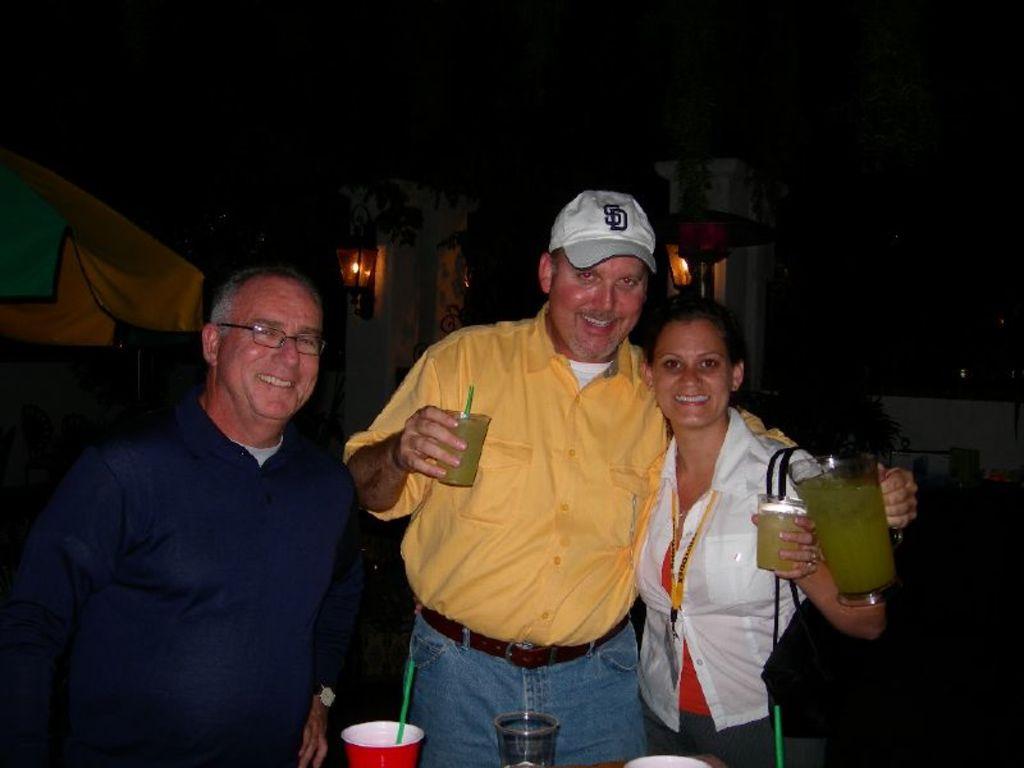What letters is the man sporting on his ballcap?
Provide a succinct answer. Sd. 